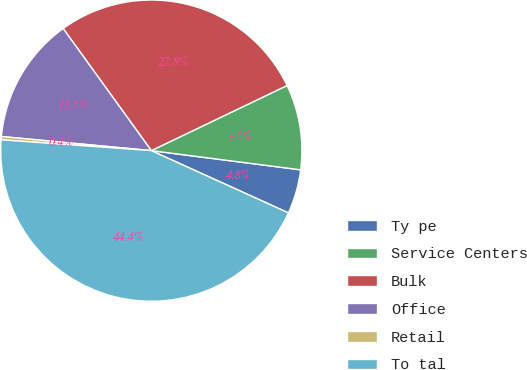<chart> <loc_0><loc_0><loc_500><loc_500><pie_chart><fcel>Ty pe<fcel>Service Centers<fcel>Bulk<fcel>Office<fcel>Retail<fcel>To tal<nl><fcel>4.75%<fcel>9.15%<fcel>27.83%<fcel>13.55%<fcel>0.35%<fcel>44.35%<nl></chart> 